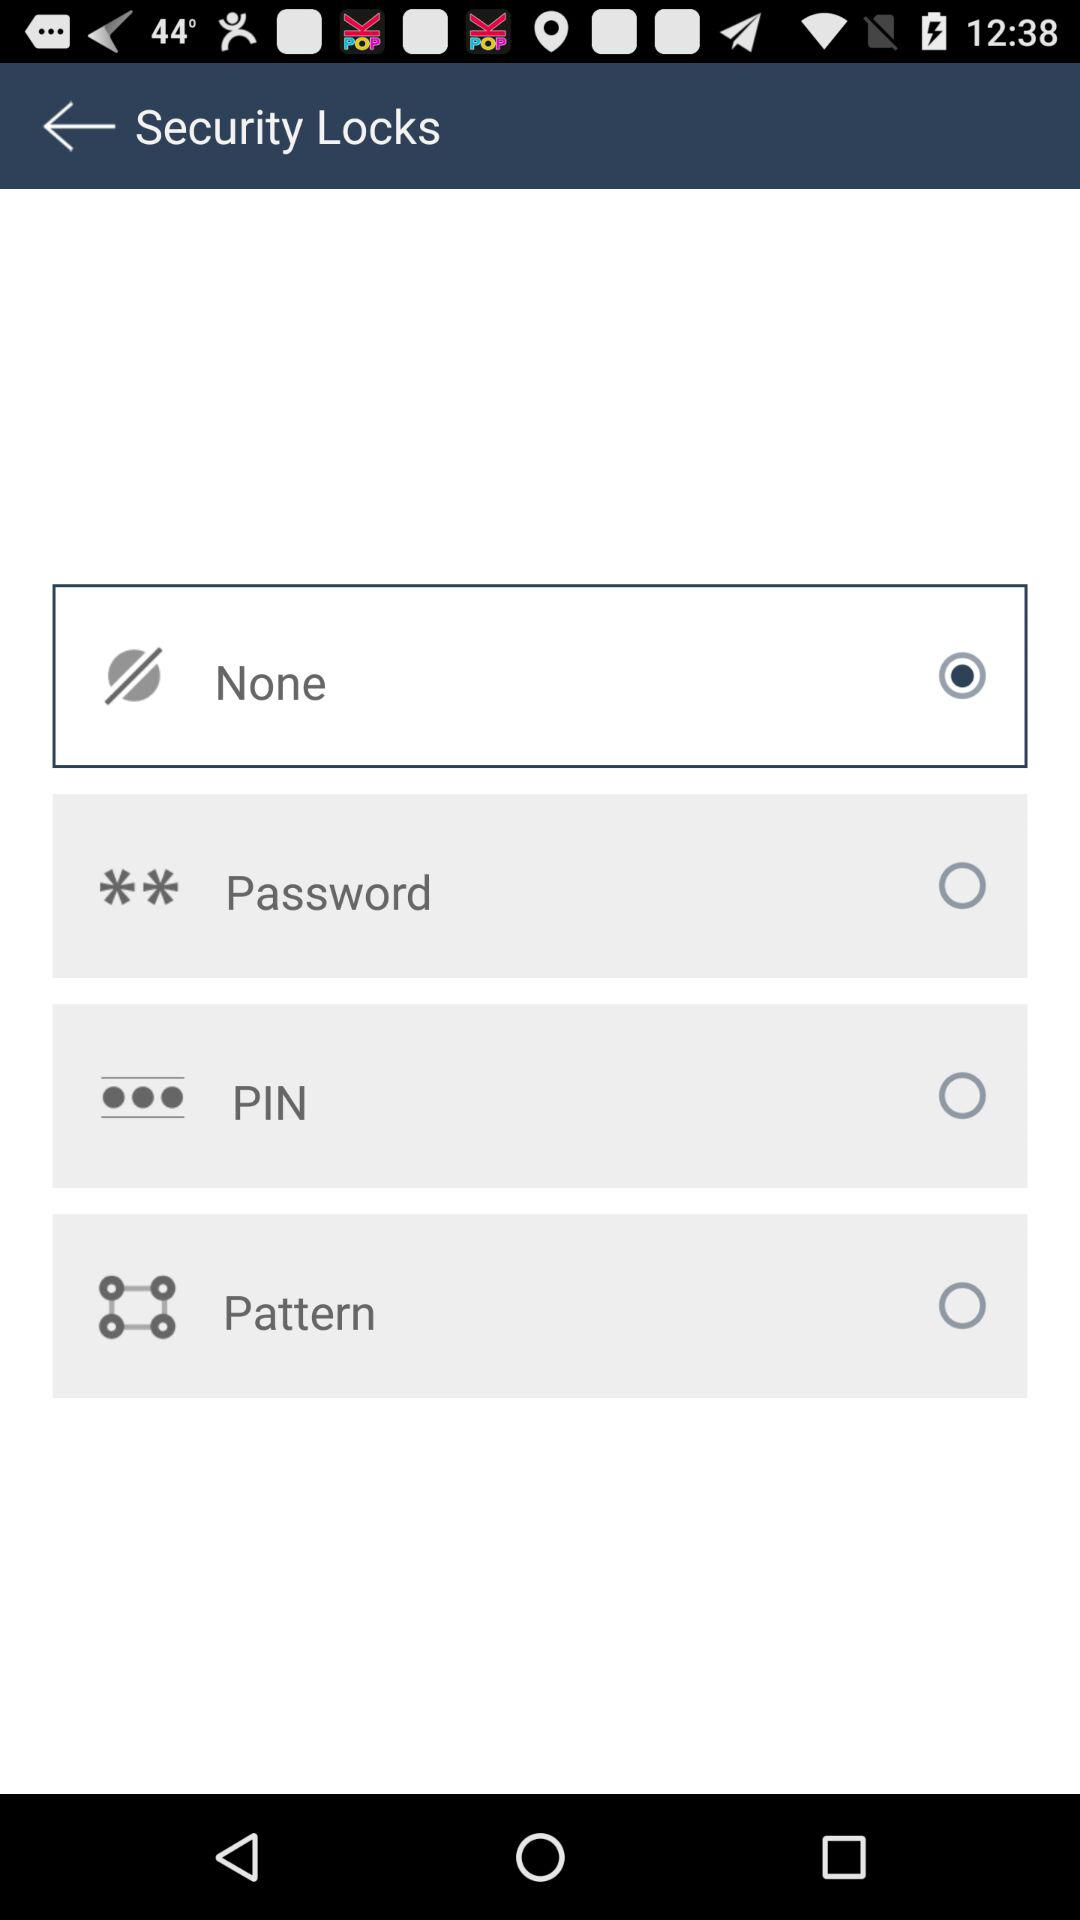How many security locks are available?
Answer the question using a single word or phrase. 4 